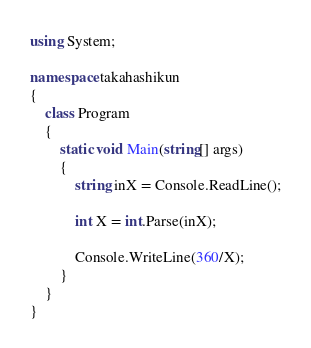Convert code to text. <code><loc_0><loc_0><loc_500><loc_500><_C#_>using System;

namespace takahashikun
{
    class Program
    {
        static void Main(string[] args)
        {
            string inX = Console.ReadLine();

            int X = int.Parse(inX);

            Console.WriteLine(360/X);
        }
    }
}
</code> 